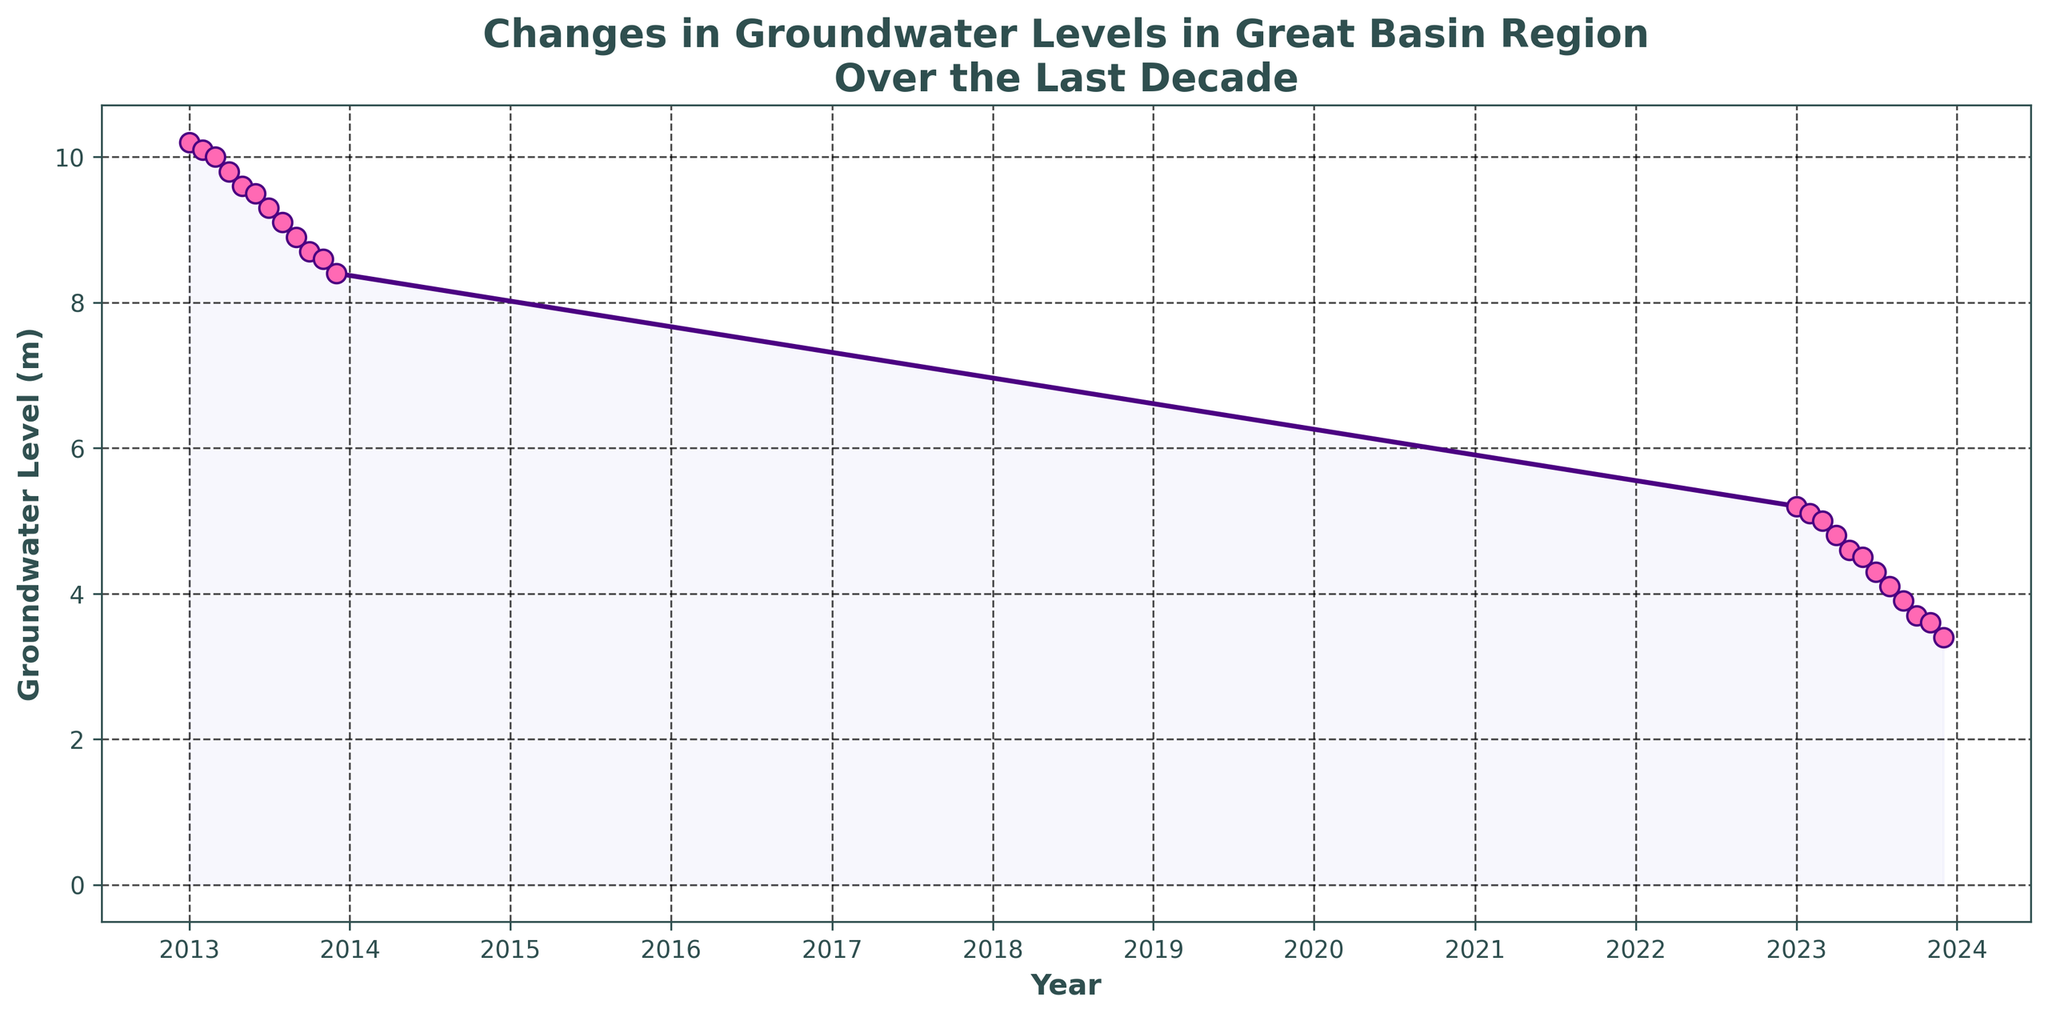How many data points are plotted on the graph? The figure tracks groundwater levels from January 2013 to December 2023, providing one data point per month. There are 12 months per year and the data span 11 years, giving a total of 12 * 11 = 132 data points.
Answer: 132 During which year did the groundwater level seem to decrease the most on average? We need to compare the change in groundwater levels month-to-month within each year. The year 2023 started at 5.2 meters in January and dropped to 3.4 meters by December, a decrease of 1.8 meters. Checking the other years, no other year shows such a significant drop.
Answer: 2023 Approximately what was the groundwater level at the start and end of the time period shown in the graph? We identify the groundwater levels at January 2013 and December 2023 on the x-axis. The level starts around 10.2 meters in January 2013 and falls to about 3.4 meters by December 2023.
Answer: 10.2 meters (start), 3.4 meters (end) Was there any period when the groundwater level remained roughly constant? Periods where the line is relatively flat indicate that the groundwater levels remained constant. All parts show a slight decline, with no flat sections suggesting constant levels.
Answer: No Compare the groundwater levels between January 2013 and January 2023. Groundwater levels in January 2013 were around 10.2 meters, while by January 2023 they dropped to about 5.2 meters. The difference is 10.2 - 5.2 = 5 meters.
Answer: 5 meters drop What is the overall trend of the groundwater levels in the Great Basin Region over the past decade? The general direction of the plotted line from January 2013 to December 2023 shows a continuous decline. This indicates an overall decreasing trend in groundwater levels throughout this period.
Answer: Decreasing Compare the groundwater levels in July 2013 versus July 2023. From the figure, July 2013's groundwater level is about 9.3 meters, while July 2023 is around 4.3 meters. The difference is between these values.
Answer: Approximately 5 meters lower in July 2023 Which month in 2023 experienced the lowest groundwater level? By examining the plotted data points month by month for 2023, December shows the lowest level, around 3.4 meters.
Answer: December What's the change in groundwater level from January 2023 to December 2023? To find this, subtract the December 2023 level from the January 2023 level (5.2 - 3.4).
Answer: 1.8 meters decrease 